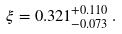<formula> <loc_0><loc_0><loc_500><loc_500>\xi = 0 . 3 2 1 ^ { + 0 . 1 1 0 } _ { - 0 . 0 7 3 } \, .</formula> 